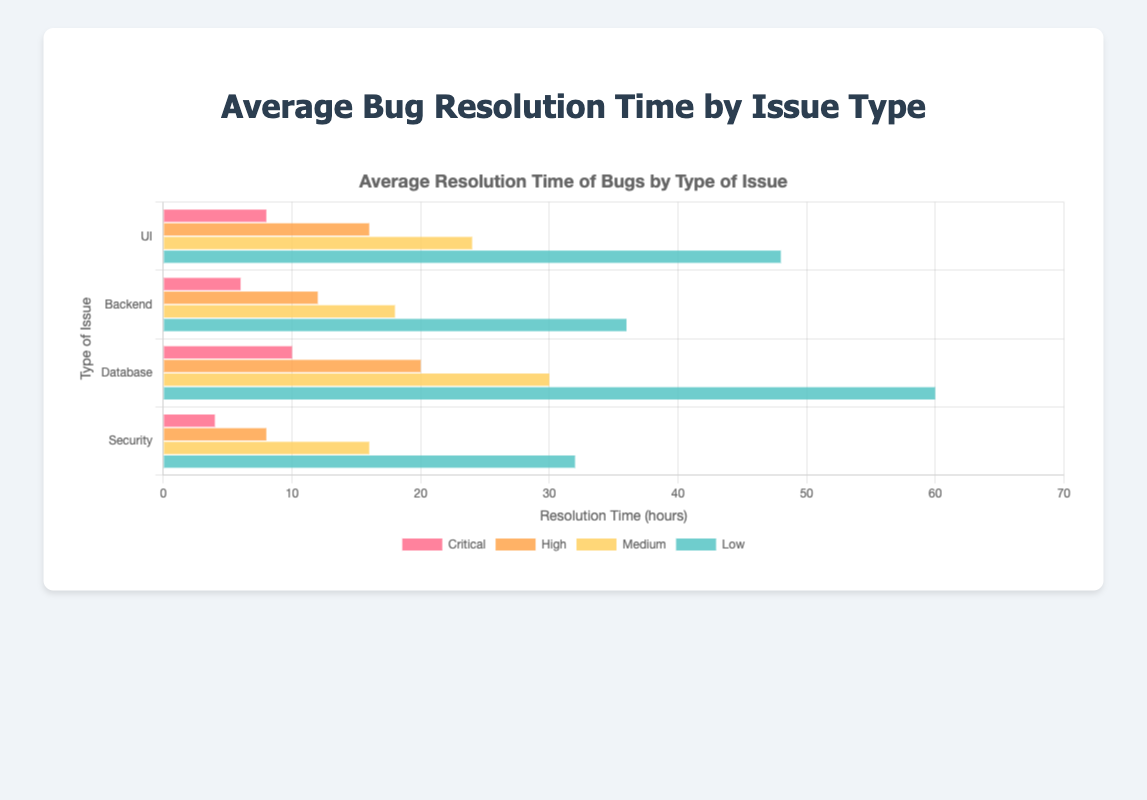What type of issue has the shortest average resolution time for critical bugs? The type of issue with the shortest average resolution time for critical bugs is the one with the smallest bar length in the Critical category. The shortest bar is for Security issues.
Answer: Security How much longer does it take to resolve a Medium backend issue compared to a Medium UI issue? The Medium backend issue takes 18 hours, and the Medium UI issue takes 24 hours. The difference in resolution time is 24 - 18 = 6 hours.
Answer: 6 hours Which type of issue has the longest average resolution time for low severity bugs? The type of issue with the longest average resolution time for low severity bugs is the one with the longest bar in the Low category. The longest bar is for Database issues.
Answer: Database What is the total average resolution time for all severity levels of UI issues? Sum the average resolution times: 8 (Critical) + 16 (High) + 24 (Medium) + 48 (Low) = 96 hours.
Answer: 96 hours How does the average resolution time for a critical database issue compare to a critical UI issue? The critical database issue has an average resolution time of 10 hours, while the critical UI issue has 8 hours. The database issue takes 10 - 8 = 2 hours longer.
Answer: 2 hours longer Which severity level has the highest average resolution time overall? Look for the highest bar length across all types and severity levels. The highest bar is the Low severity level for Database issues, with 60 hours.
Answer: Low Calculate the average resolution time for High severity across all issue types. Sum the resolution times for High severity: 16 (UI) + 12 (Backend) + 20 (Database) + 8 (Security) = 56 hours. The average is 56 / 4 = 14 hours.
Answer: 14 hours Is the resolution time for Security issues consistently shorter than for Database issues across all severity levels? Compare the bars for Security and Database issues at all severity levels (Critical, High, Medium, Low). Security has shorter bars than Database for all severity levels.
Answer: Yes What is the difference in resolution times between the fastest and slowest resolving issues for Low severity bugs? The fastest is Security with 32 hours and the slowest is Database with 60 hours. The difference is 60 - 32 = 28 hours.
Answer: 28 hours What proportion of the UI issue's total resolution time is spent on Low severity bugs? The total resolution time for UI issues is 96 hours, with 48 hours for Low severity. The proportion is 48 / 96 = 0.5 or 50%.
Answer: 50% 